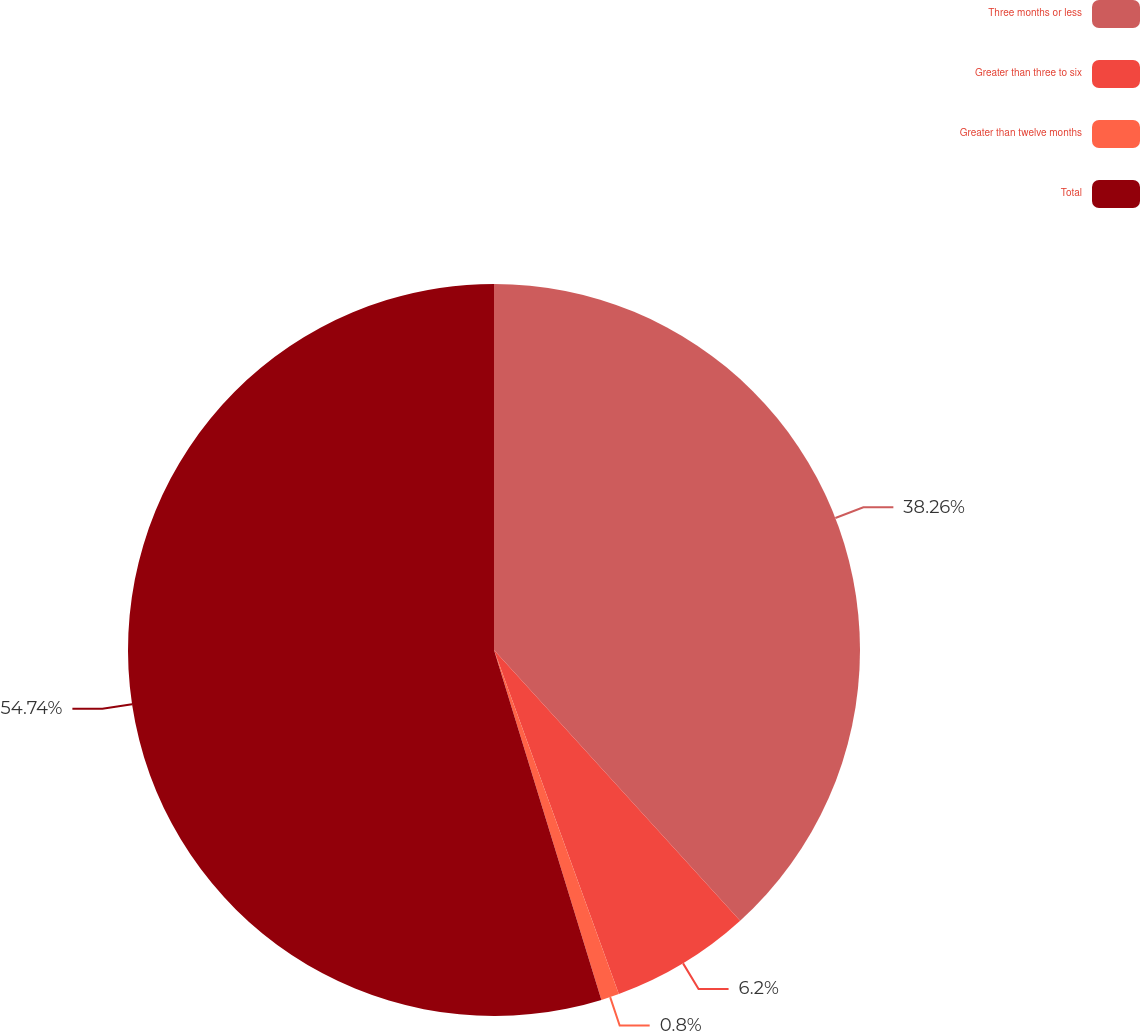<chart> <loc_0><loc_0><loc_500><loc_500><pie_chart><fcel>Three months or less<fcel>Greater than three to six<fcel>Greater than twelve months<fcel>Total<nl><fcel>38.26%<fcel>6.2%<fcel>0.8%<fcel>54.74%<nl></chart> 